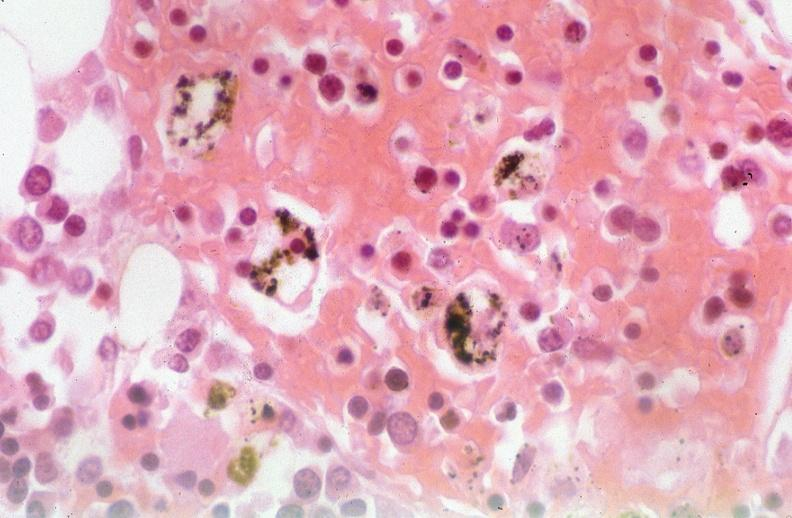s respiratory present?
Answer the question using a single word or phrase. Yes 